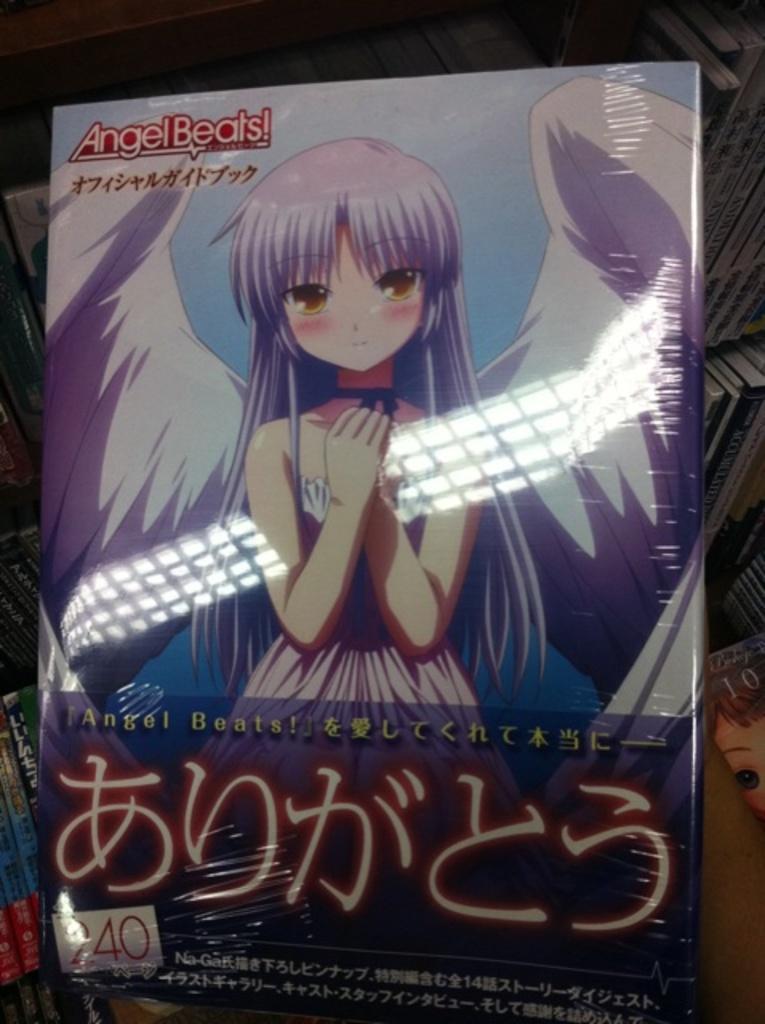Can you describe this image briefly? Cartoon woman picture on this book. Background there are a number of books. 